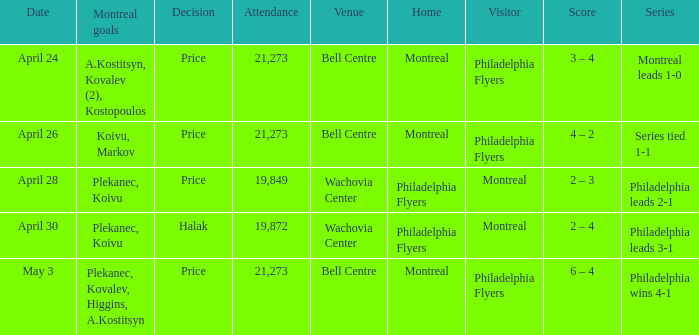What was the average attendance when the decision was price and montreal were the visitors? 19849.0. 